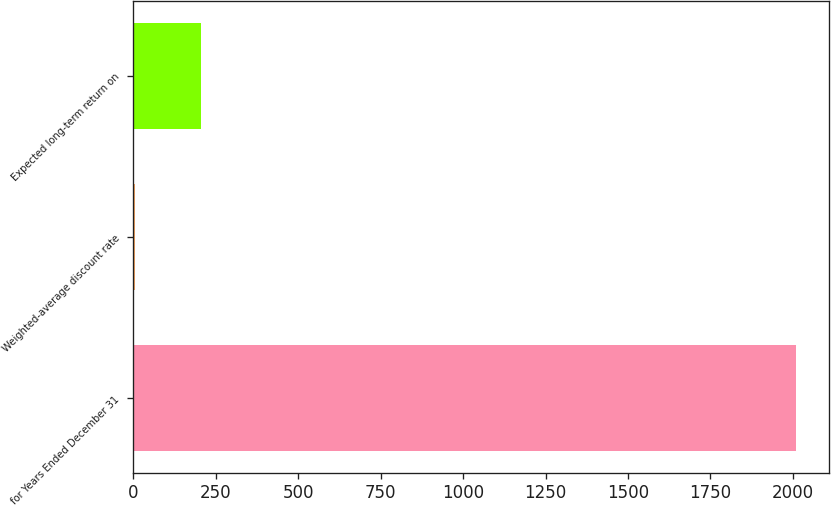Convert chart. <chart><loc_0><loc_0><loc_500><loc_500><bar_chart><fcel>for Years Ended December 31<fcel>Weighted-average discount rate<fcel>Expected long-term return on<nl><fcel>2009<fcel>7<fcel>207.2<nl></chart> 